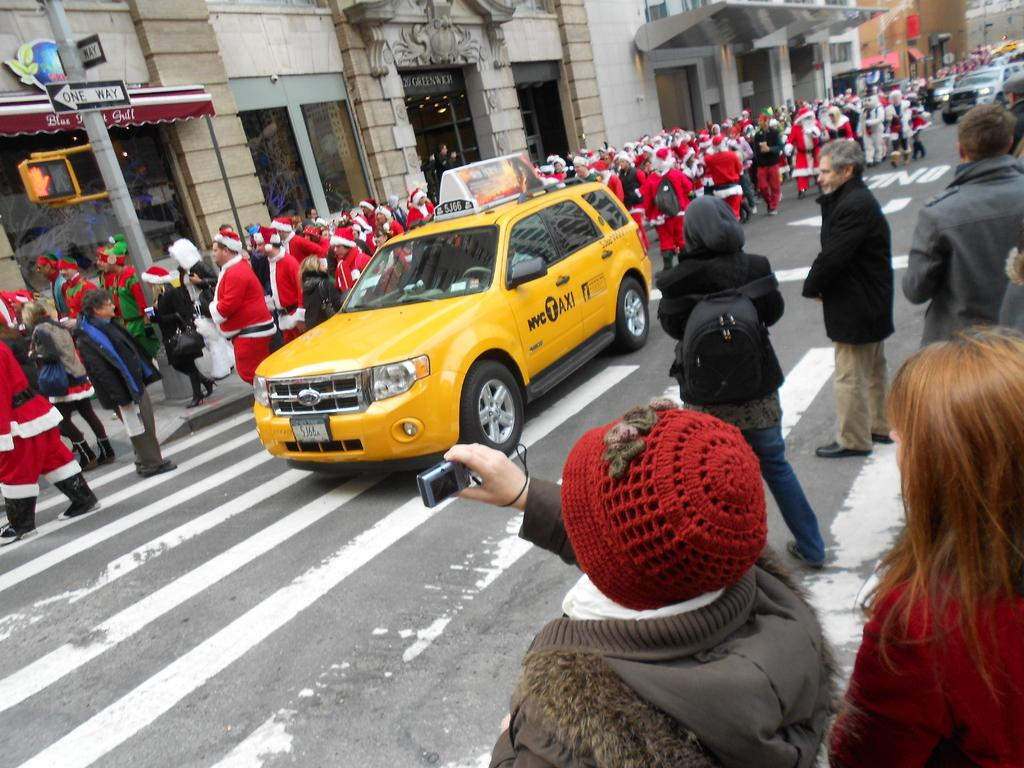<image>
Give a short and clear explanation of the subsequent image. A yellow taxi in the street with a line of santa claus. 